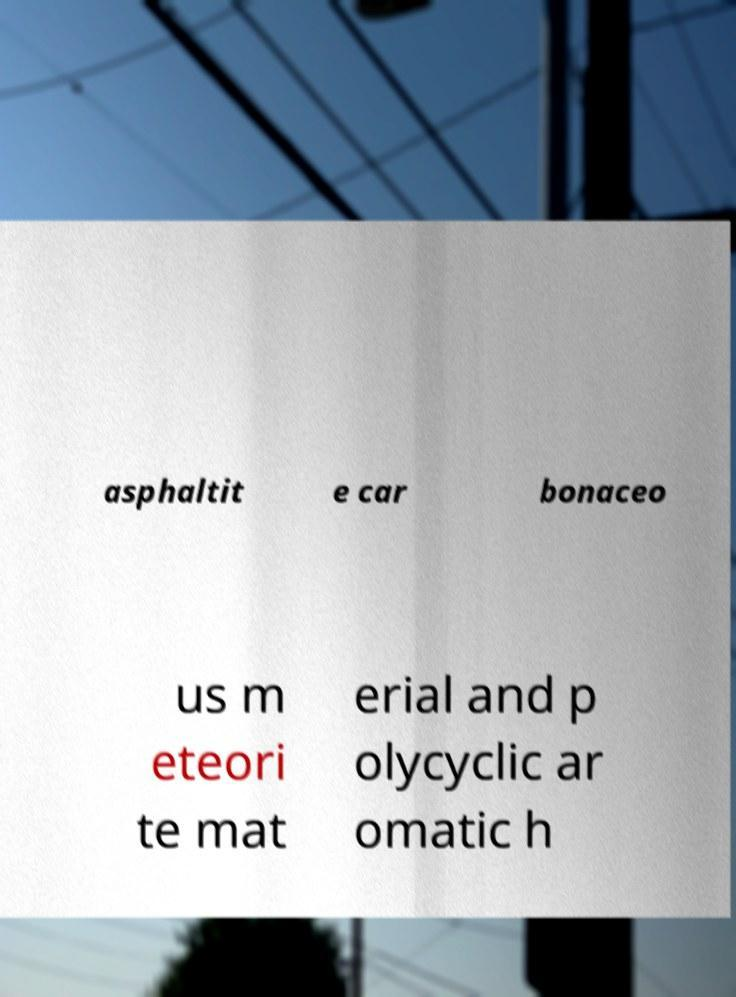Could you extract and type out the text from this image? asphaltit e car bonaceo us m eteori te mat erial and p olycyclic ar omatic h 